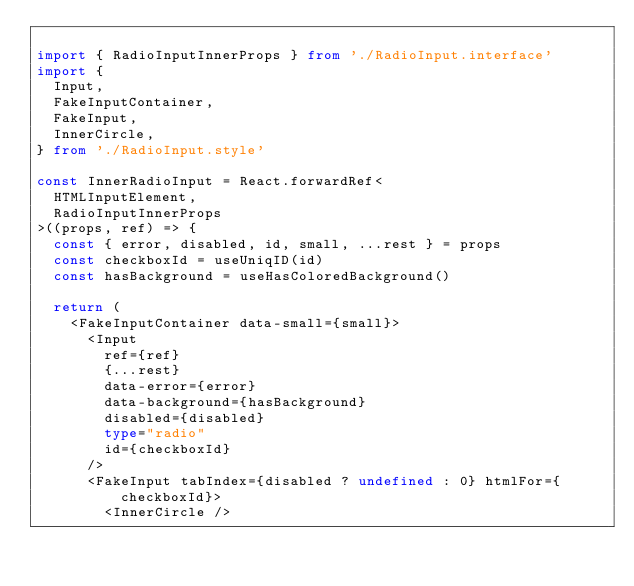Convert code to text. <code><loc_0><loc_0><loc_500><loc_500><_TypeScript_>
import { RadioInputInnerProps } from './RadioInput.interface'
import {
  Input,
  FakeInputContainer,
  FakeInput,
  InnerCircle,
} from './RadioInput.style'

const InnerRadioInput = React.forwardRef<
  HTMLInputElement,
  RadioInputInnerProps
>((props, ref) => {
  const { error, disabled, id, small, ...rest } = props
  const checkboxId = useUniqID(id)
  const hasBackground = useHasColoredBackground()

  return (
    <FakeInputContainer data-small={small}>
      <Input
        ref={ref}
        {...rest}
        data-error={error}
        data-background={hasBackground}
        disabled={disabled}
        type="radio"
        id={checkboxId}
      />
      <FakeInput tabIndex={disabled ? undefined : 0} htmlFor={checkboxId}>
        <InnerCircle /></code> 